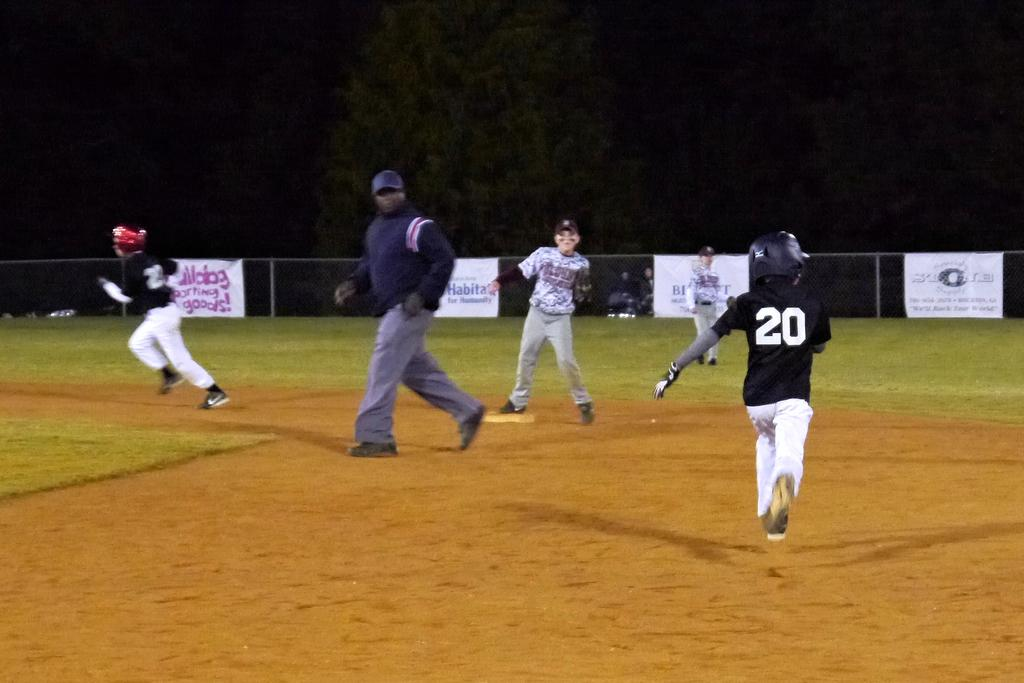<image>
Summarize the visual content of the image. Player number 20 is running the bases in a field with a Bulldog sporting goods sign on the fence. 